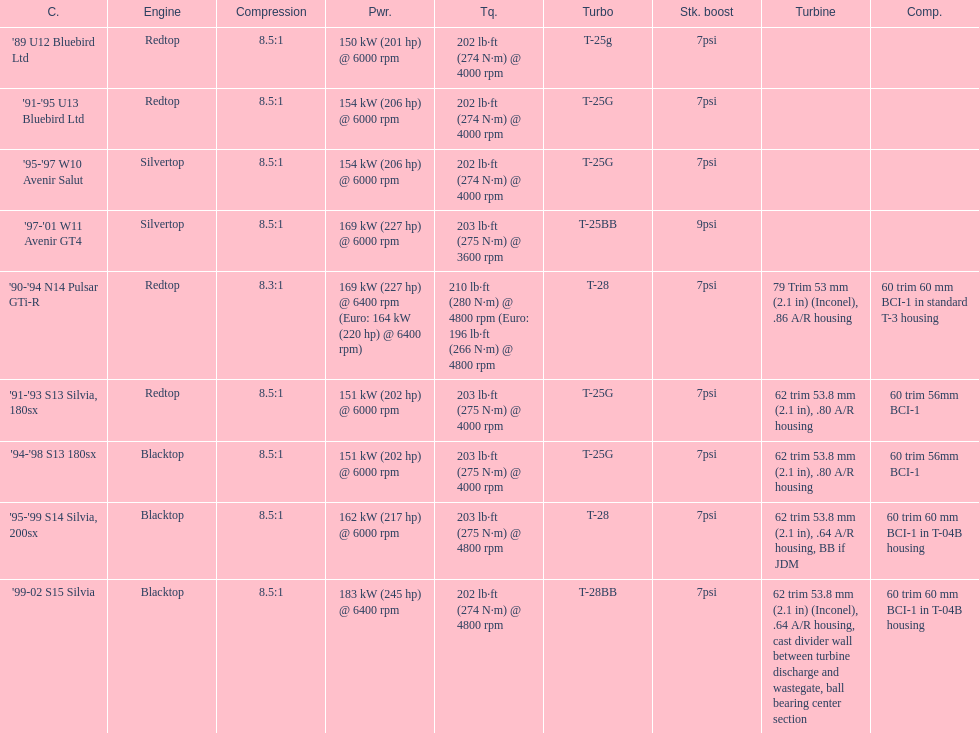Which engine has the smallest compression rate? '90-'94 N14 Pulsar GTi-R. 